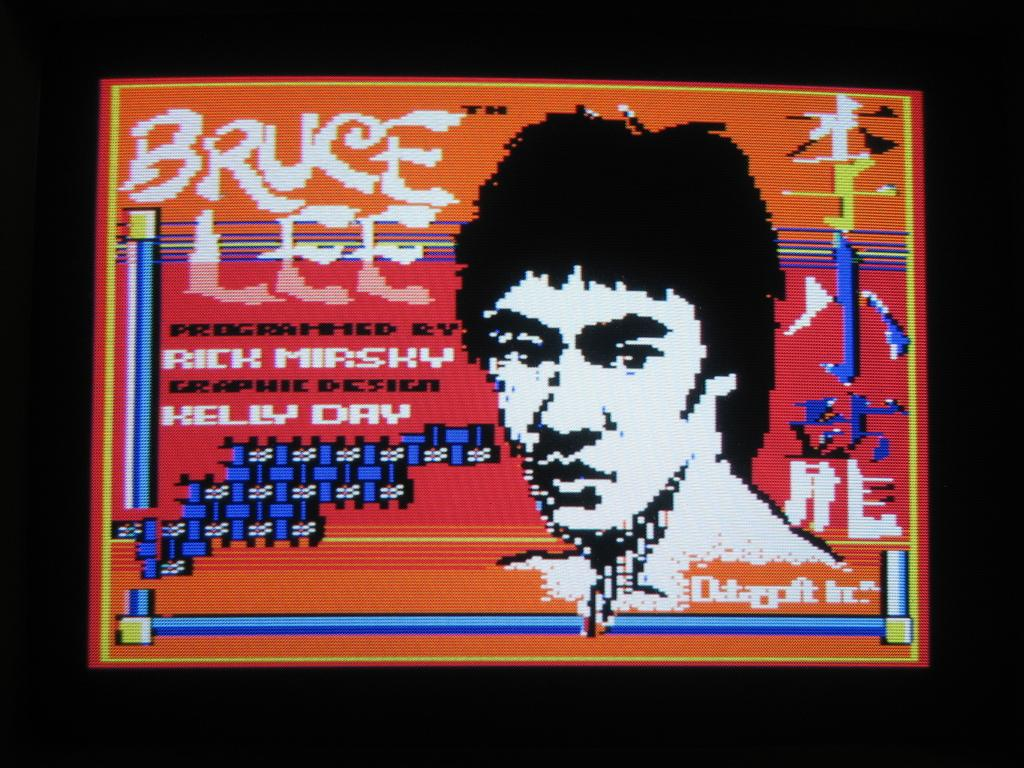What type of image is being described? The image appears to be an animated poster. What can be found within the image besides the animation? There is text in the image. Can you describe any human elements in the image? There is a person's face in the image. How many beds are visible in the image? There are no beds present in the image. What type of weather condition is depicted in the image? The image does not depict any weather conditions, such as fog. 